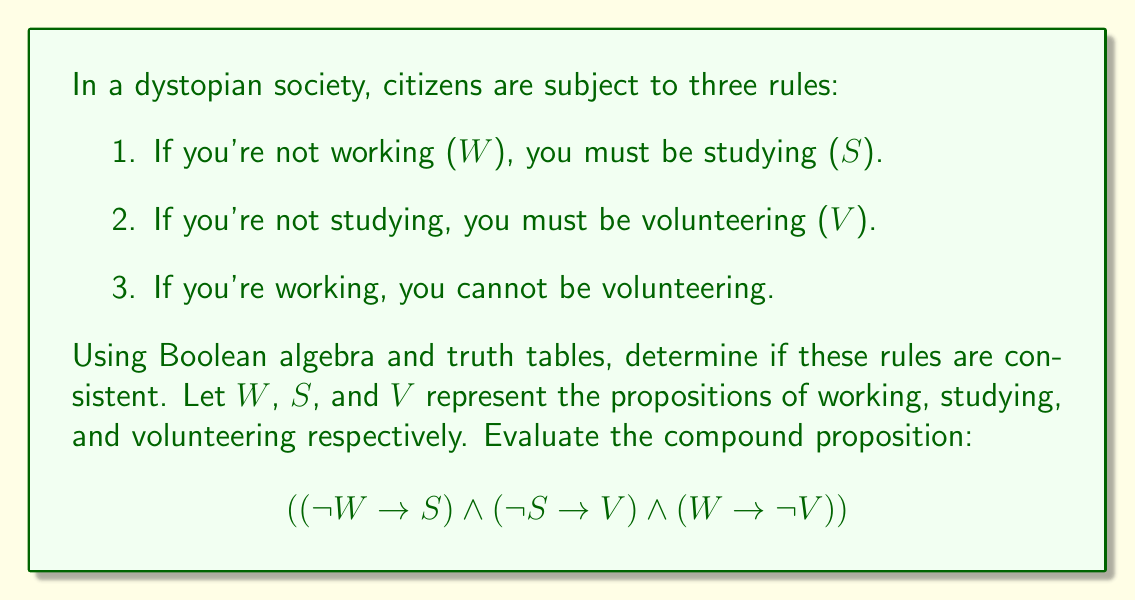What is the answer to this math problem? To evaluate the consistency of these rules, we need to construct a truth table for the compound proposition and check if there's at least one row where the result is true.

Step 1: Identify the individual propositions
W: Working
S: Studying
V: Volunteering

Step 2: Construct the truth table

We'll evaluate each rule separately and then combine them:

1. $(\neg W \rightarrow S)$
2. $(\neg S \rightarrow V)$
3. $(W \rightarrow \neg V)$

Here's the truth table:

$$\begin{array}{|c|c|c|c|c|c|c|c|}
\hline
W & S & V & \neg W & \neg S & \neg V & (\neg W \rightarrow S) & (\neg S \rightarrow V) & (W \rightarrow \neg V) & \text{Result} \\
\hline
0 & 0 & 0 & 1 & 1 & 1 & 0 & 0 & 1 & 0 \\
0 & 0 & 1 & 1 & 1 & 0 & 0 & 1 & 1 & 0 \\
0 & 1 & 0 & 1 & 0 & 1 & 1 & 1 & 1 & 1 \\
0 & 1 & 1 & 1 & 0 & 0 & 1 & 1 & 1 & 1 \\
1 & 0 & 0 & 0 & 1 & 1 & 1 & 0 & 1 & 0 \\
1 & 0 & 1 & 0 & 1 & 0 & 1 & 1 & 0 & 0 \\
1 & 1 & 0 & 0 & 0 & 1 & 1 & 1 & 1 & 1 \\
1 & 1 & 1 & 0 & 0 & 0 & 1 & 1 & 0 & 0 \\
\hline
\end{array}$$

Step 3: Analyze the results

We can see that there are three rows where the result is true (1):
1. When W = 0, S = 1, V = 0
2. When W = 0, S = 1, V = 1
3. When W = 1, S = 1, V = 0

Since there is at least one row where the result is true, we can conclude that the rules are consistent.
Answer: The rules are consistent. 